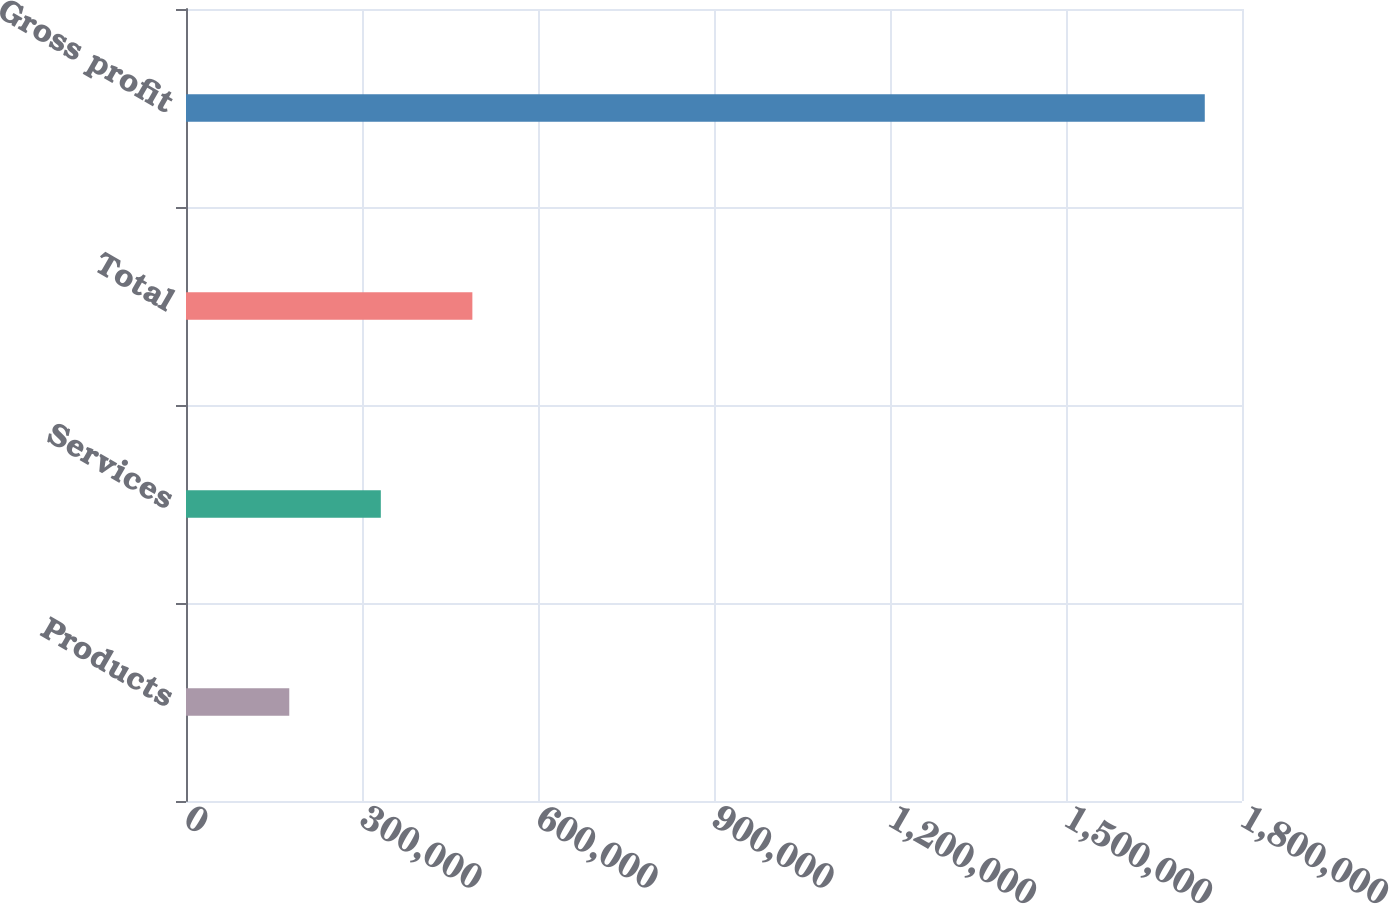Convert chart to OTSL. <chart><loc_0><loc_0><loc_500><loc_500><bar_chart><fcel>Products<fcel>Services<fcel>Total<fcel>Gross profit<nl><fcel>176032<fcel>332084<fcel>488137<fcel>1.73656e+06<nl></chart> 